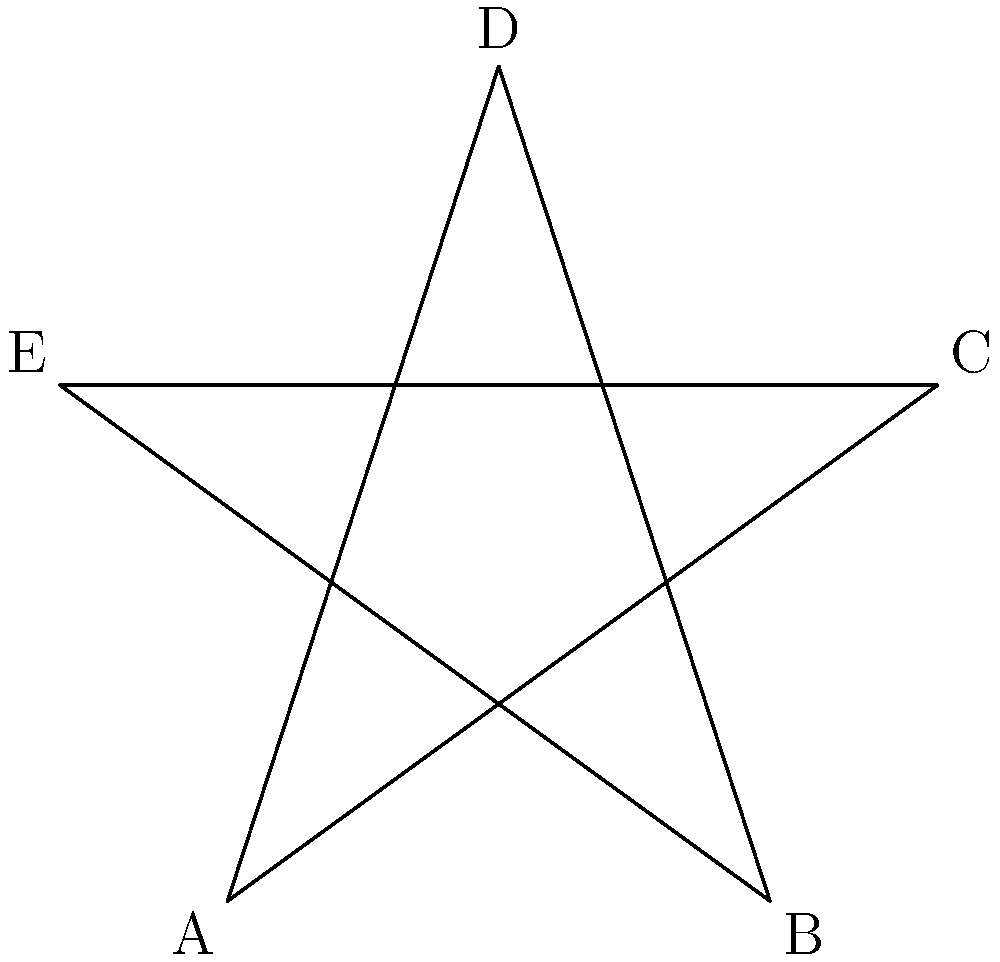In this celestial-inspired star polygon, representing the cosmic imagery often found in poetry, what is the measure of angle $\angle CAD$ if the star is regular (all angles are congruent)? To solve this problem, let's follow these cosmic steps:

1) In a regular star polygon, all internal angles are congruent.

2) The star has 5 points, so it's formed by connecting every 2nd point of a regular pentagon.

3) In a regular pentagon, each internal angle measures $\frac{(5-2) \times 180°}{5} = 108°$.

4) The star angle $\angle CAD$ is supplementary to the pentagon's internal angle:
   $180° - 108° = 72°$

5) However, this $72°$ angle is divided into two equal parts by the line AD.

6) Therefore, $\angle CAD = \frac{72°}{2} = 36°$

This angle of $36°$ represents the harmonious symmetry often celebrated in cosmic poetry, where each part contributes to a greater whole.
Answer: $36°$ 